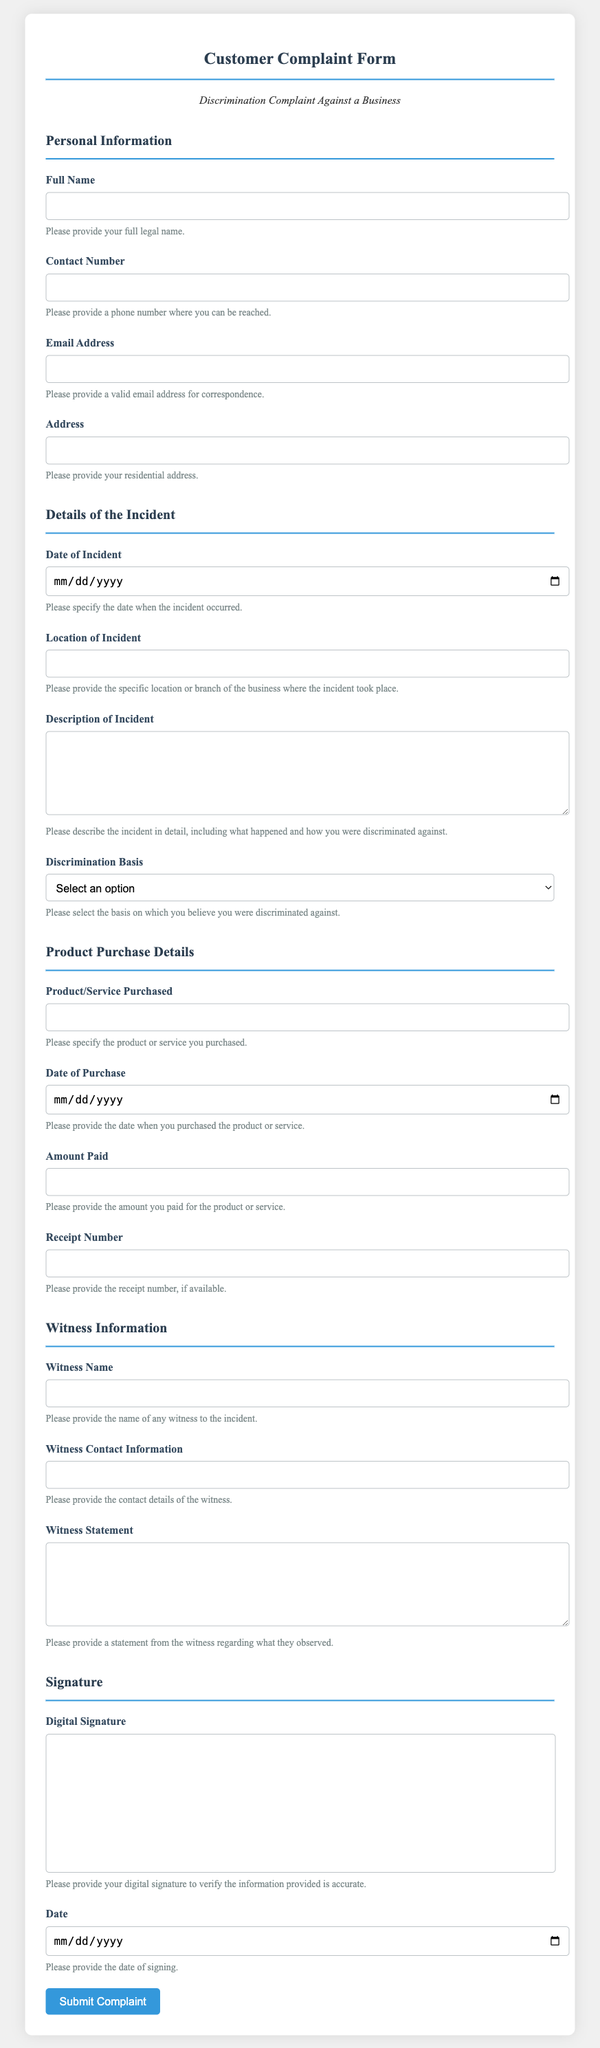What is the title of the document? The title is clearly stated in the heading of the document as it captures the purpose of the form.
Answer: Customer Complaint Form - Discrimination Complaint Against a Business What section asks for the date of the incident? The section titled "Details of the Incident" contains the input field for the date of the incident.
Answer: Details of the Incident Which option is NOT a basis for discrimination on the form? The select options are stated in the "Discrimination Basis" section, which lists valid choices.
Answer: None What type of information is captured under "Product Purchase Details"? This section collects vital information regarding the product or service that is relevant to the complaint.
Answer: Product/Service Purchased, Date of Purchase, Amount Paid, Receipt Number What is required in the "Witness Information" section? The section contains fields to gather details about the witness to the incident.
Answer: Witness Name, Witness Contact Information, Witness Statement What is the format for providing a digital signature? The form includes a specific area designated for the digital signature, highlighting its purpose.
Answer: Digital Signature How many options are available for the basis of discrimination? This is determined by counting the selections provided in the relevant dropdown menu of the form.
Answer: Six 